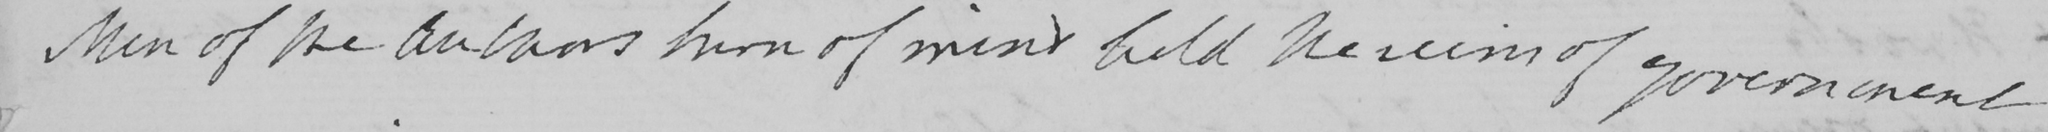Can you read and transcribe this handwriting? Men of the Authors turn of mind hold the reins of government 